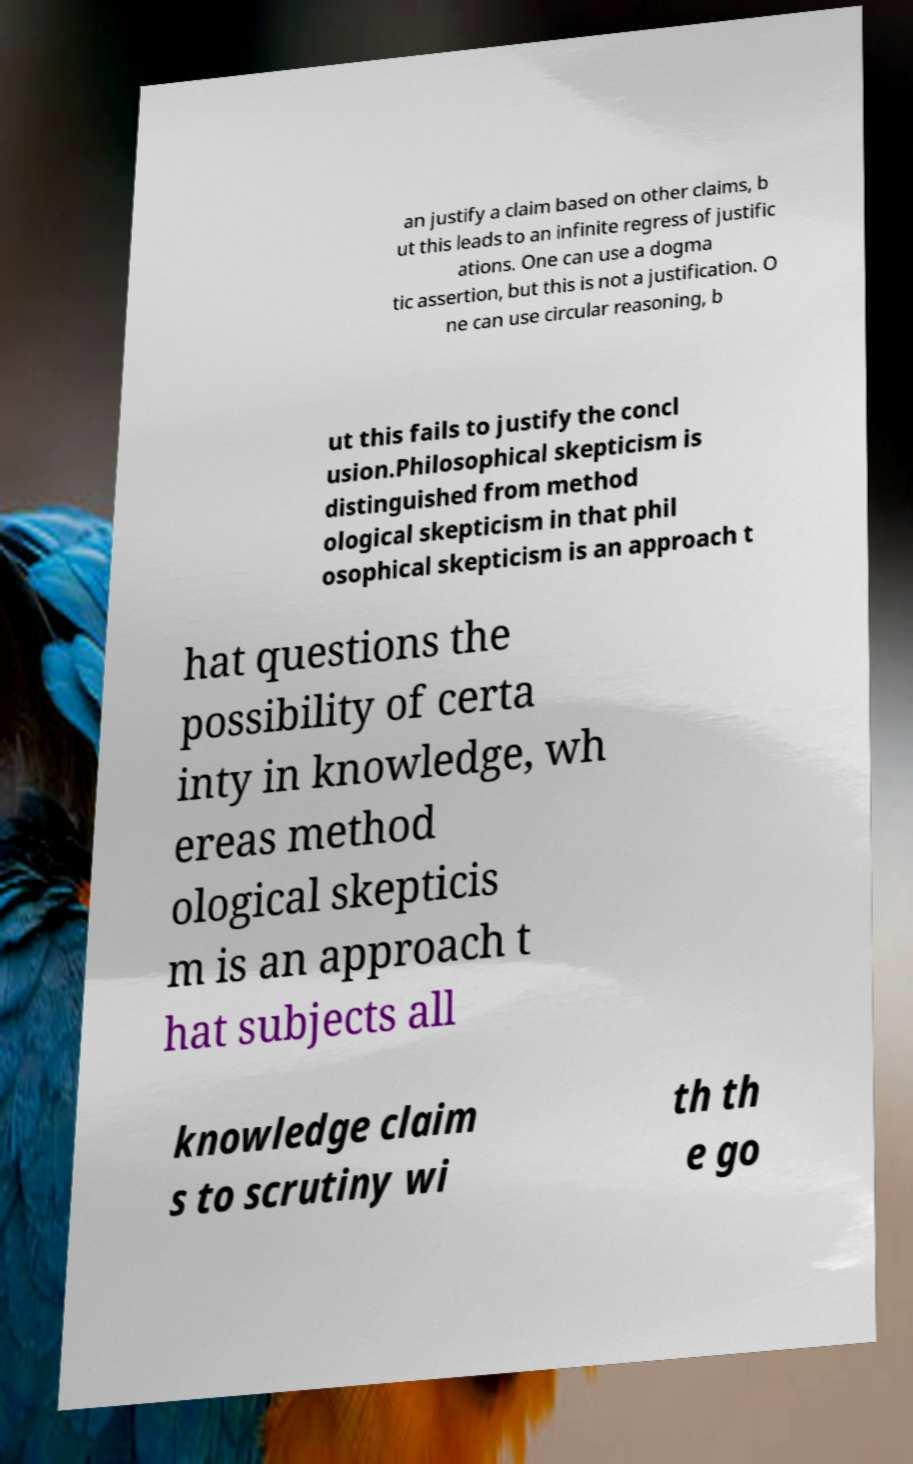Can you read and provide the text displayed in the image?This photo seems to have some interesting text. Can you extract and type it out for me? an justify a claim based on other claims, b ut this leads to an infinite regress of justific ations. One can use a dogma tic assertion, but this is not a justification. O ne can use circular reasoning, b ut this fails to justify the concl usion.Philosophical skepticism is distinguished from method ological skepticism in that phil osophical skepticism is an approach t hat questions the possibility of certa inty in knowledge, wh ereas method ological skepticis m is an approach t hat subjects all knowledge claim s to scrutiny wi th th e go 